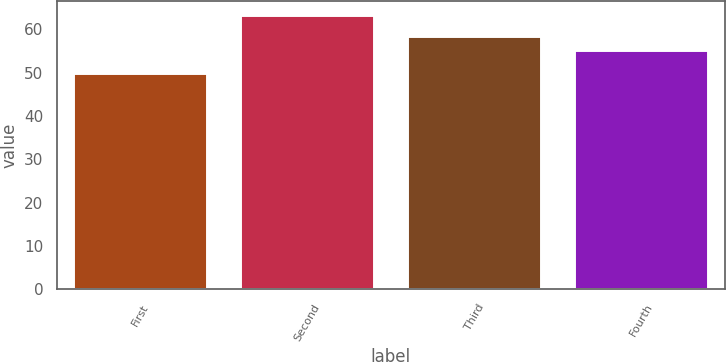<chart> <loc_0><loc_0><loc_500><loc_500><bar_chart><fcel>First<fcel>Second<fcel>Third<fcel>Fourth<nl><fcel>49.97<fcel>63.3<fcel>58.4<fcel>55.25<nl></chart> 